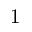Convert formula to latex. <formula><loc_0><loc_0><loc_500><loc_500>1</formula> 